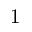Convert formula to latex. <formula><loc_0><loc_0><loc_500><loc_500>1</formula> 